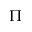<formula> <loc_0><loc_0><loc_500><loc_500>\Pi</formula> 